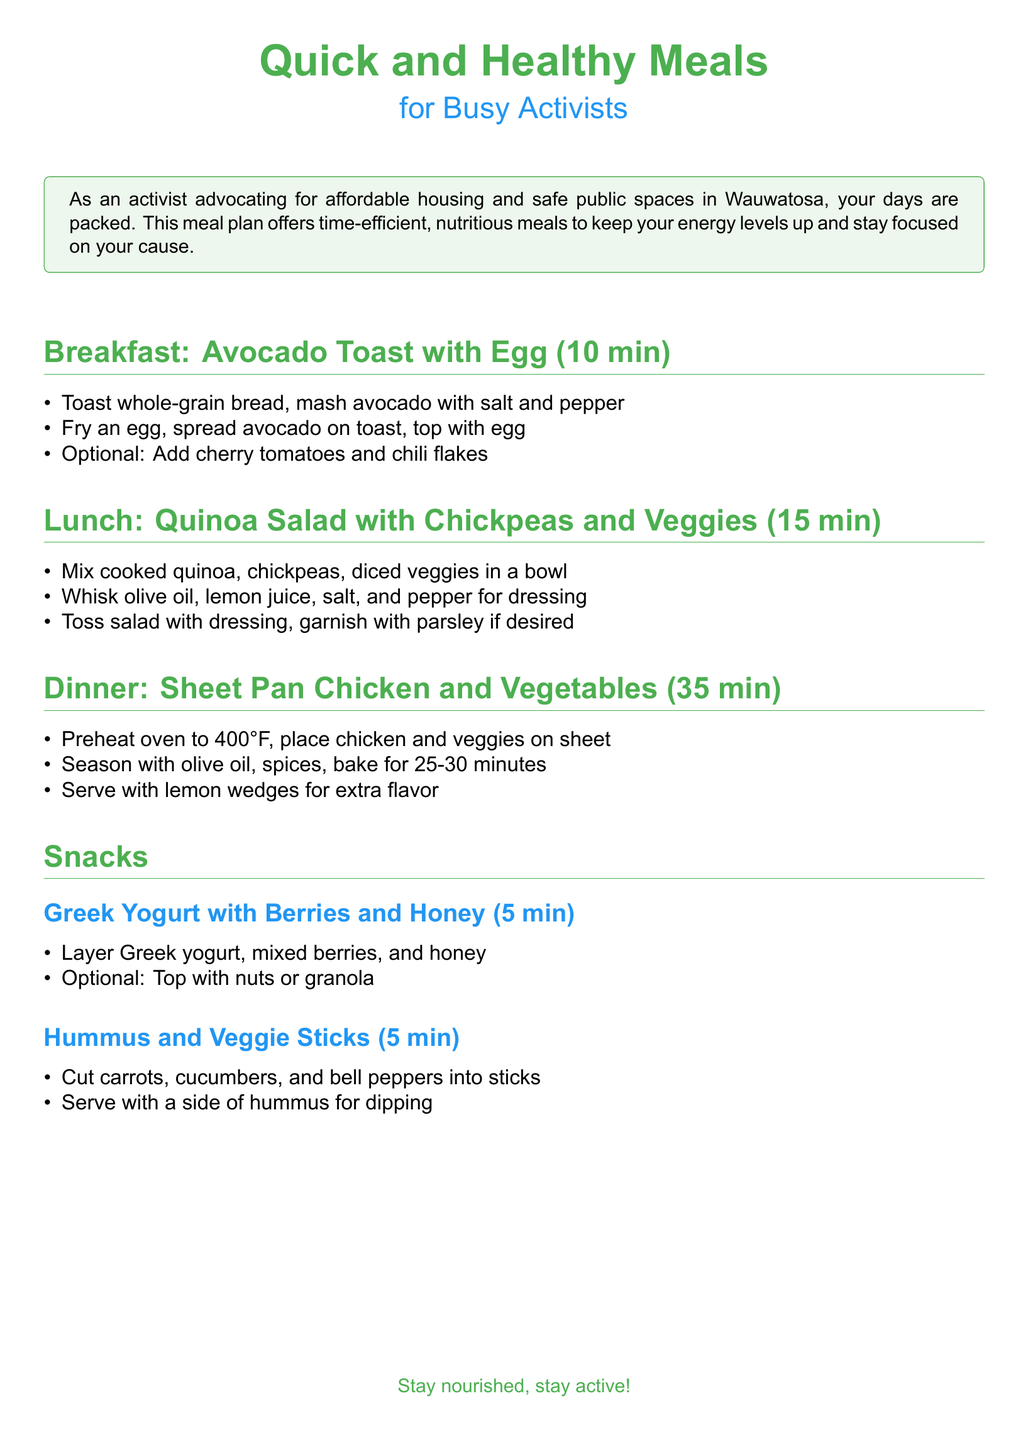What is the first breakfast recipe mentioned? The document lists "Avocado Toast with Egg" as the first breakfast recipe.
Answer: Avocado Toast with Egg How much time does the quinoa salad take to prepare? The document states that the quinoa salad takes 15 minutes to prepare.
Answer: 15 min What ingredient is suggested for topping the Greek yogurt? The document mentions "nuts or granola" as optional toppings for Greek yogurt.
Answer: nuts or granola What is the main protein source in the dinner recipe? The dinner recipe is centered around "chicken" as the main protein source.
Answer: chicken How long should the chicken and vegetables be baked? The document specifies that the chicken and vegetables should be baked for 25-30 minutes.
Answer: 25-30 minutes What is an optional ingredient for the avocado toast? The document suggests "cherry tomatoes and chili flakes" as optional ingredients for the avocado toast.
Answer: cherry tomatoes and chili flakes How many snacks are listed in the document? The document lists two different snacks: Greek yogurt with berries and honey, and hummus with veggie sticks.
Answer: 2 What type of meal plan is this document about? The document centers around "Quick and Healthy Meals" for people with busy schedules, specifically activists.
Answer: Quick and Healthy Meals 